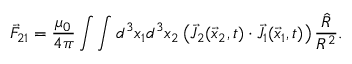Convert formula to latex. <formula><loc_0><loc_0><loc_500><loc_500>\vec { F } _ { 2 1 } = \frac { \mu _ { 0 } } { 4 \pi } \int \int d ^ { 3 } x _ { 1 } d ^ { 3 } x _ { 2 } \left ( \vec { J } _ { 2 } ( \vec { x } _ { 2 } , t ) \cdot \vec { J } _ { 1 } ( \vec { x } _ { 1 } , t ) \right ) \frac { \hat { R } } { R ^ { 2 } } .</formula> 